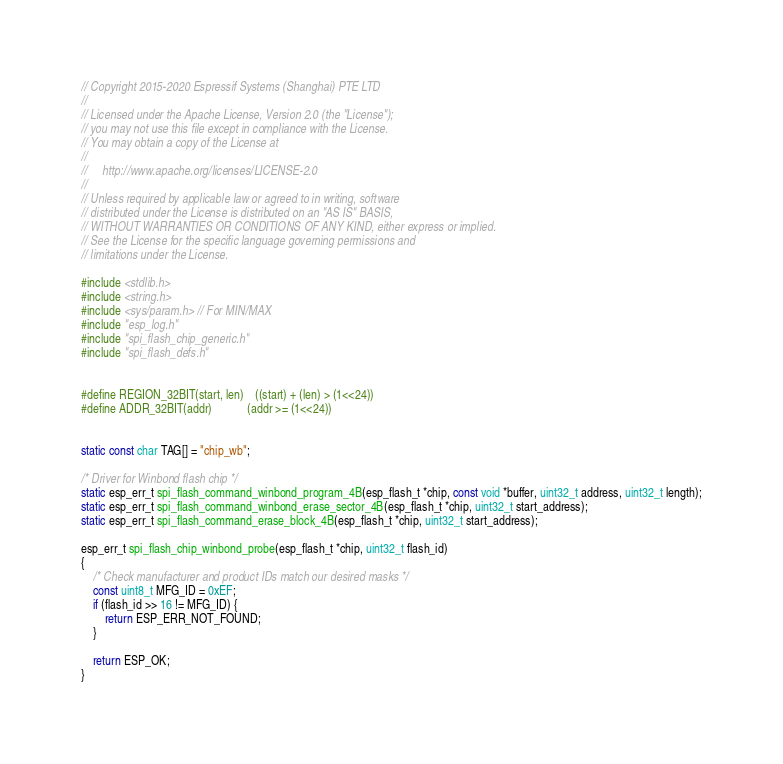Convert code to text. <code><loc_0><loc_0><loc_500><loc_500><_C_>// Copyright 2015-2020 Espressif Systems (Shanghai) PTE LTD
//
// Licensed under the Apache License, Version 2.0 (the "License");
// you may not use this file except in compliance with the License.
// You may obtain a copy of the License at
//
//     http://www.apache.org/licenses/LICENSE-2.0
//
// Unless required by applicable law or agreed to in writing, software
// distributed under the License is distributed on an "AS IS" BASIS,
// WITHOUT WARRANTIES OR CONDITIONS OF ANY KIND, either express or implied.
// See the License for the specific language governing permissions and
// limitations under the License.

#include <stdlib.h>
#include <string.h>
#include <sys/param.h> // For MIN/MAX
#include "esp_log.h"
#include "spi_flash_chip_generic.h"
#include "spi_flash_defs.h"


#define REGION_32BIT(start, len)    ((start) + (len) > (1<<24))
#define ADDR_32BIT(addr)            (addr >= (1<<24))


static const char TAG[] = "chip_wb";

/* Driver for Winbond flash chip */
static esp_err_t spi_flash_command_winbond_program_4B(esp_flash_t *chip, const void *buffer, uint32_t address, uint32_t length);
static esp_err_t spi_flash_command_winbond_erase_sector_4B(esp_flash_t *chip, uint32_t start_address);
static esp_err_t spi_flash_command_erase_block_4B(esp_flash_t *chip, uint32_t start_address);

esp_err_t spi_flash_chip_winbond_probe(esp_flash_t *chip, uint32_t flash_id)
{
    /* Check manufacturer and product IDs match our desired masks */
    const uint8_t MFG_ID = 0xEF;
    if (flash_id >> 16 != MFG_ID) {
        return ESP_ERR_NOT_FOUND;
    }

    return ESP_OK;
}
</code> 